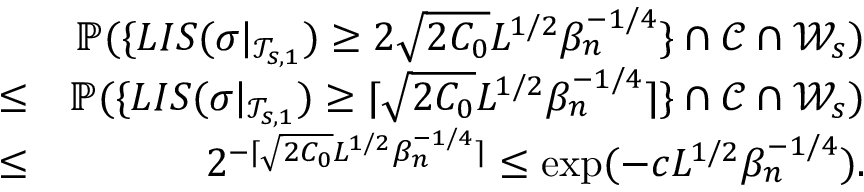Convert formula to latex. <formula><loc_0><loc_0><loc_500><loc_500>\begin{array} { r l r } & { \mathbb { P } ( \{ L I S ( \sigma | _ { \mathcal { T } _ { s , 1 } } ) \geq 2 \sqrt { 2 C _ { 0 } } L ^ { 1 \slash 2 } \beta _ { n } ^ { - 1 \slash 4 } \} \cap \mathcal { C } \cap \mathcal { W } _ { s } ) } \\ & { \leq } & { \mathbb { P } ( \{ L I S ( \sigma | _ { \mathcal { T } _ { s , 1 } } ) \geq \lceil \sqrt { 2 C _ { 0 } } L ^ { 1 \slash 2 } \beta _ { n } ^ { - 1 \slash 4 } \rceil \} \cap \mathcal { C } \cap \mathcal { W } _ { s } ) } \\ & { \leq } & { 2 ^ { - \lceil \sqrt { 2 C _ { 0 } } L ^ { 1 \slash 2 } \beta _ { n } ^ { - 1 \slash 4 } \rceil } \leq \exp ( - c L ^ { 1 \slash 2 } \beta _ { n } ^ { - 1 \slash 4 } ) . } \end{array}</formula> 